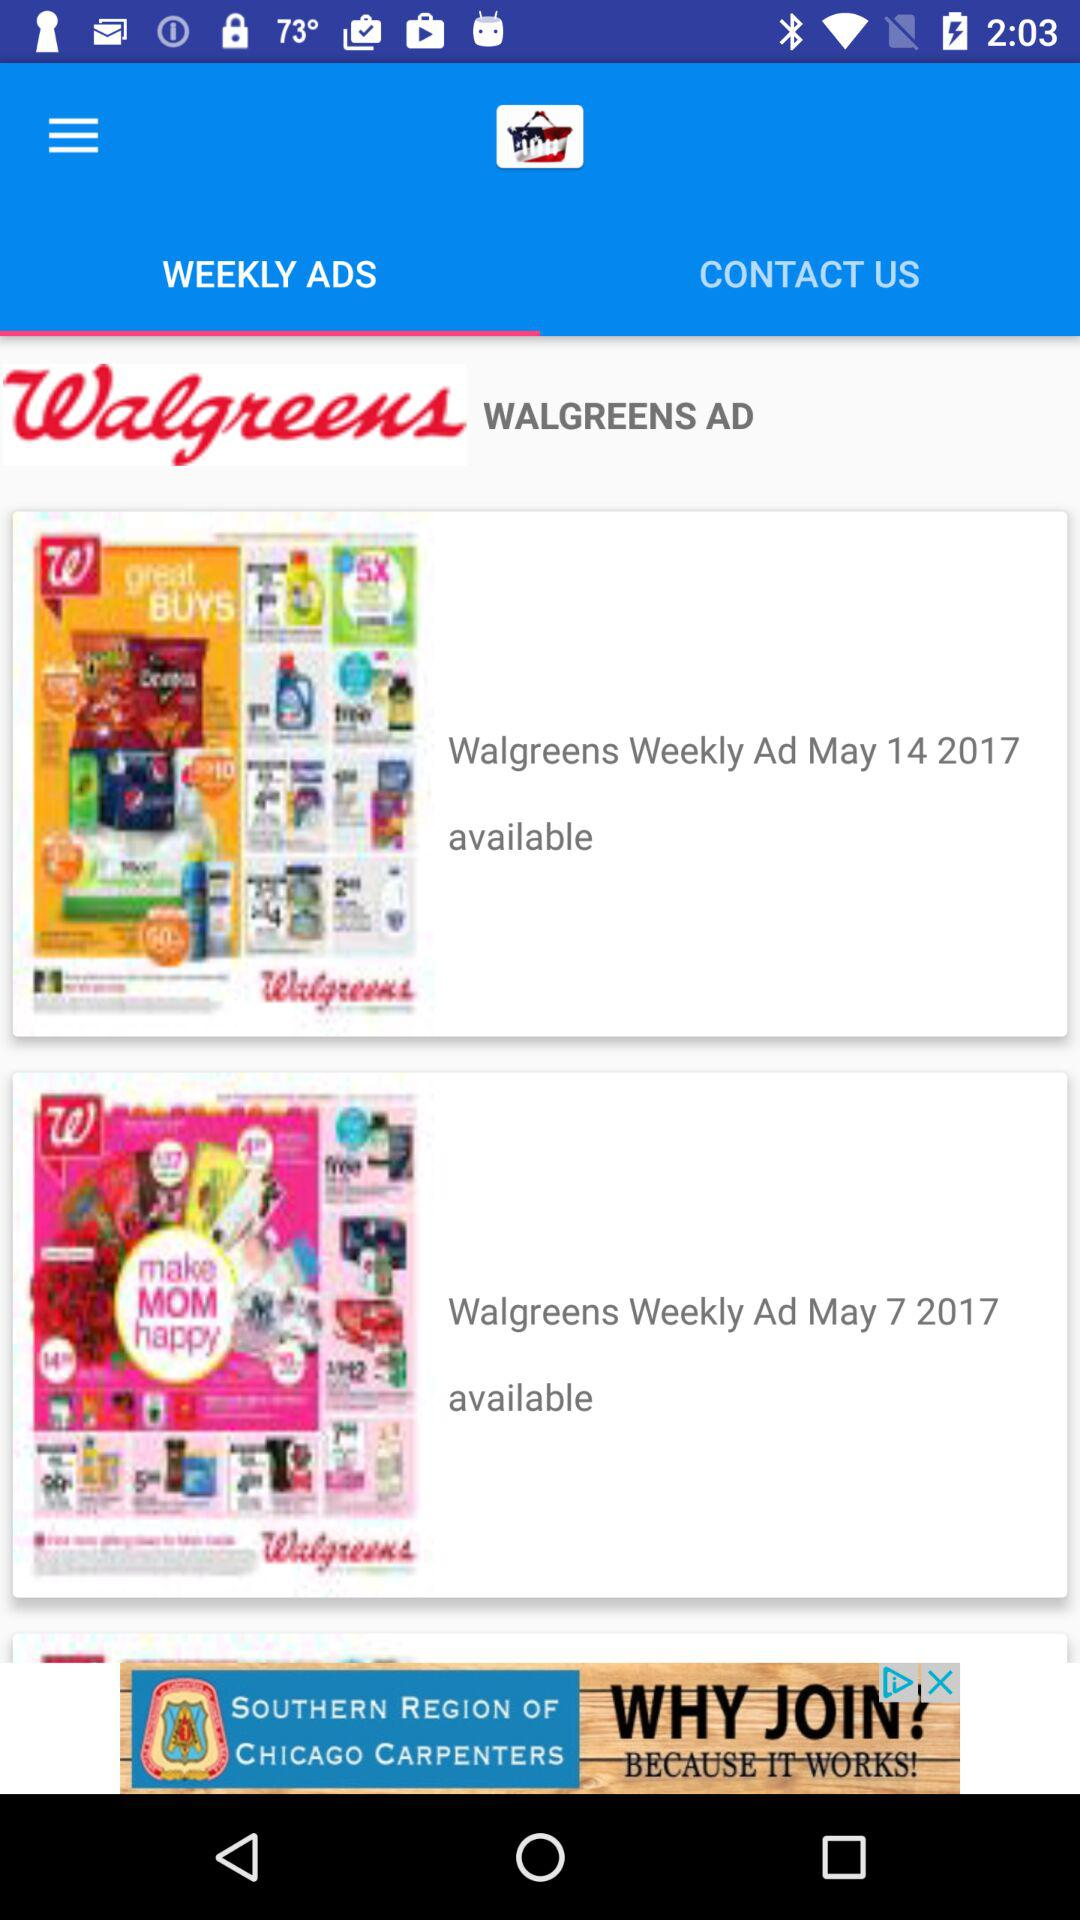What is the status of "Weekly Ad May 14 2017"? The status is "available". 